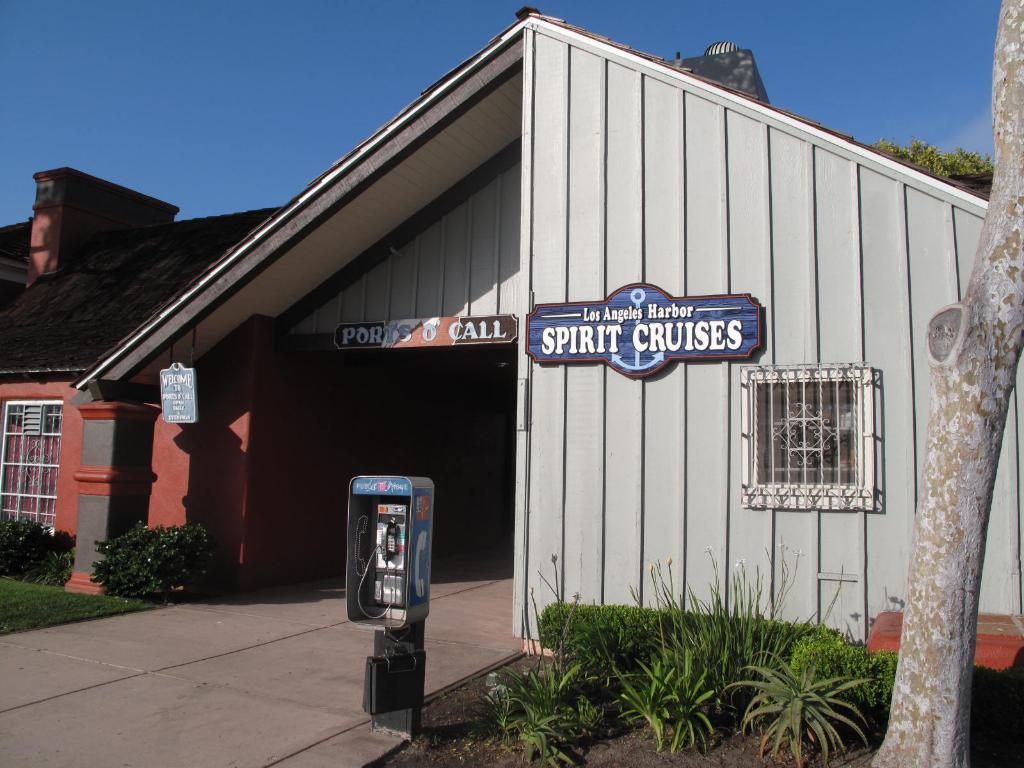What is the main subject in the center of the image? There is a house in the center of the image. What type of vegetation can be seen on the right side of the image? There are plants on the right side of the image. What type of vegetation can be seen on the left side of the image? There are plants on the left side of the image. What structure is located in the center of the image, besides the house? There is a vending pole in the center of the image. How many legs can be seen on the chessboard in the image? There is no chessboard present in the image, so it is not possible to determine the number of legs. 